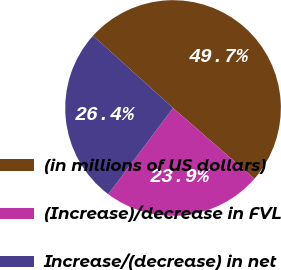Convert chart. <chart><loc_0><loc_0><loc_500><loc_500><pie_chart><fcel>(in millions of US dollars)<fcel>(Increase)/decrease in FVL<fcel>Increase/(decrease) in net<nl><fcel>49.7%<fcel>23.86%<fcel>26.44%<nl></chart> 